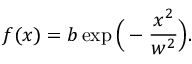Convert formula to latex. <formula><loc_0><loc_0><loc_500><loc_500>f ( x ) = b \exp \left ( - \frac { x ^ { 2 } } { w ^ { 2 } } \right ) .</formula> 